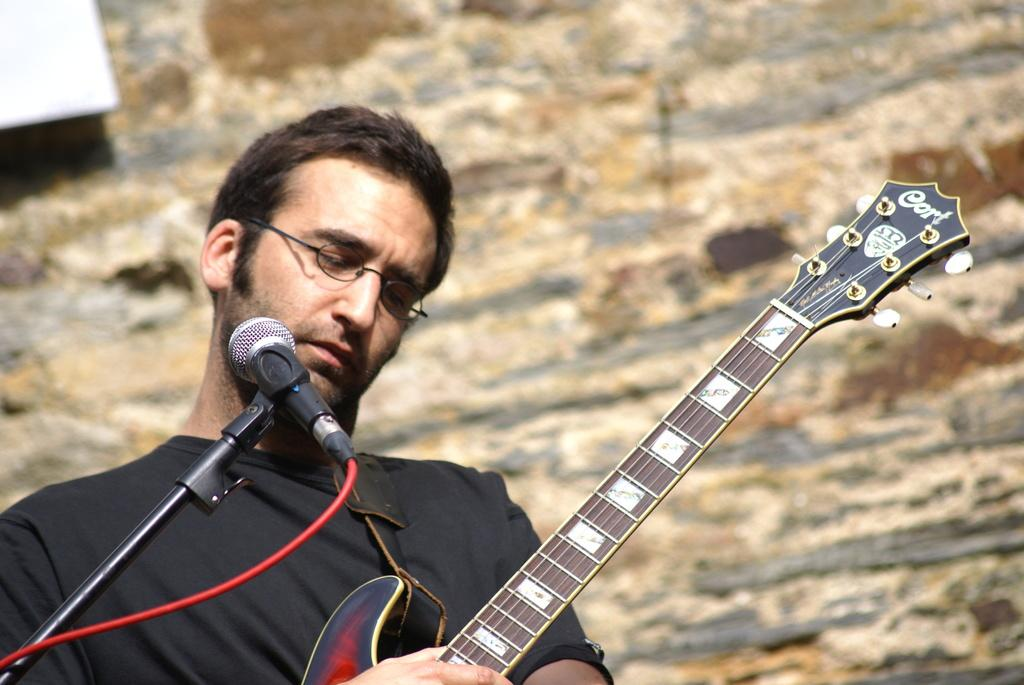Who is present in the image? There is a man in the image. Where is the man located in the image? The man is standing at the left side of the image. What is the man holding in his hands? The man is holding a guitar in his hands. What object is in front of the man? There is a microphone in front of the man. What type of feast is being prepared in the image? There is no feast present in the image; it features a man holding a guitar and standing near a microphone. How many nails can be seen in the image? There are no nails visible in the image. 